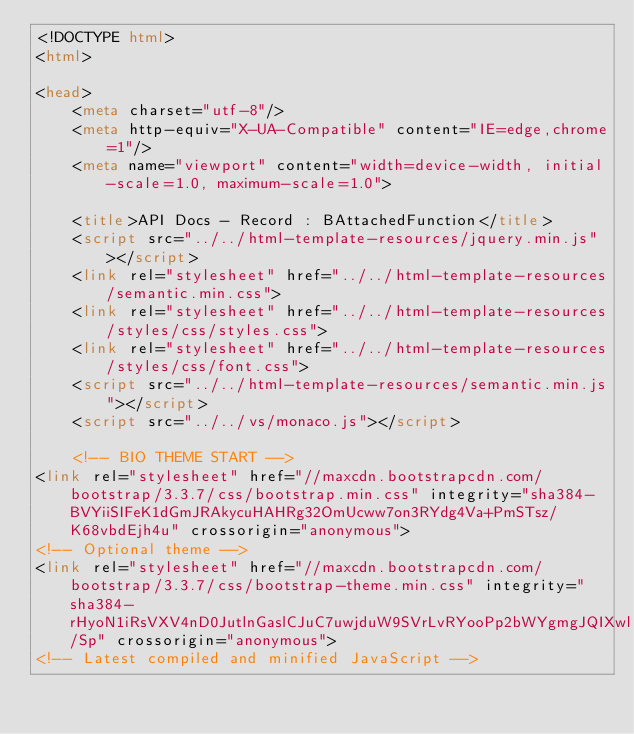Convert code to text. <code><loc_0><loc_0><loc_500><loc_500><_HTML_><!DOCTYPE html>
<html>

<head>
    <meta charset="utf-8"/>
    <meta http-equiv="X-UA-Compatible" content="IE=edge,chrome=1"/>
    <meta name="viewport" content="width=device-width, initial-scale=1.0, maximum-scale=1.0">

    <title>API Docs - Record : BAttachedFunction</title>
    <script src="../../html-template-resources/jquery.min.js"></script>
    <link rel="stylesheet" href="../../html-template-resources/semantic.min.css">
    <link rel="stylesheet" href="../../html-template-resources/styles/css/styles.css">
    <link rel="stylesheet" href="../../html-template-resources/styles/css/font.css">
    <script src="../../html-template-resources/semantic.min.js"></script>
    <script src="../../vs/monaco.js"></script>

    <!-- BIO THEME START -->
<link rel="stylesheet" href="//maxcdn.bootstrapcdn.com/bootstrap/3.3.7/css/bootstrap.min.css" integrity="sha384-BVYiiSIFeK1dGmJRAkycuHAHRg32OmUcww7on3RYdg4Va+PmSTsz/K68vbdEjh4u" crossorigin="anonymous">
<!-- Optional theme -->
<link rel="stylesheet" href="//maxcdn.bootstrapcdn.com/bootstrap/3.3.7/css/bootstrap-theme.min.css" integrity="sha384-rHyoN1iRsVXV4nD0JutlnGaslCJuC7uwjduW9SVrLvRYooPp2bWYgmgJQIXwl/Sp" crossorigin="anonymous">
<!-- Latest compiled and minified JavaScript --></code> 